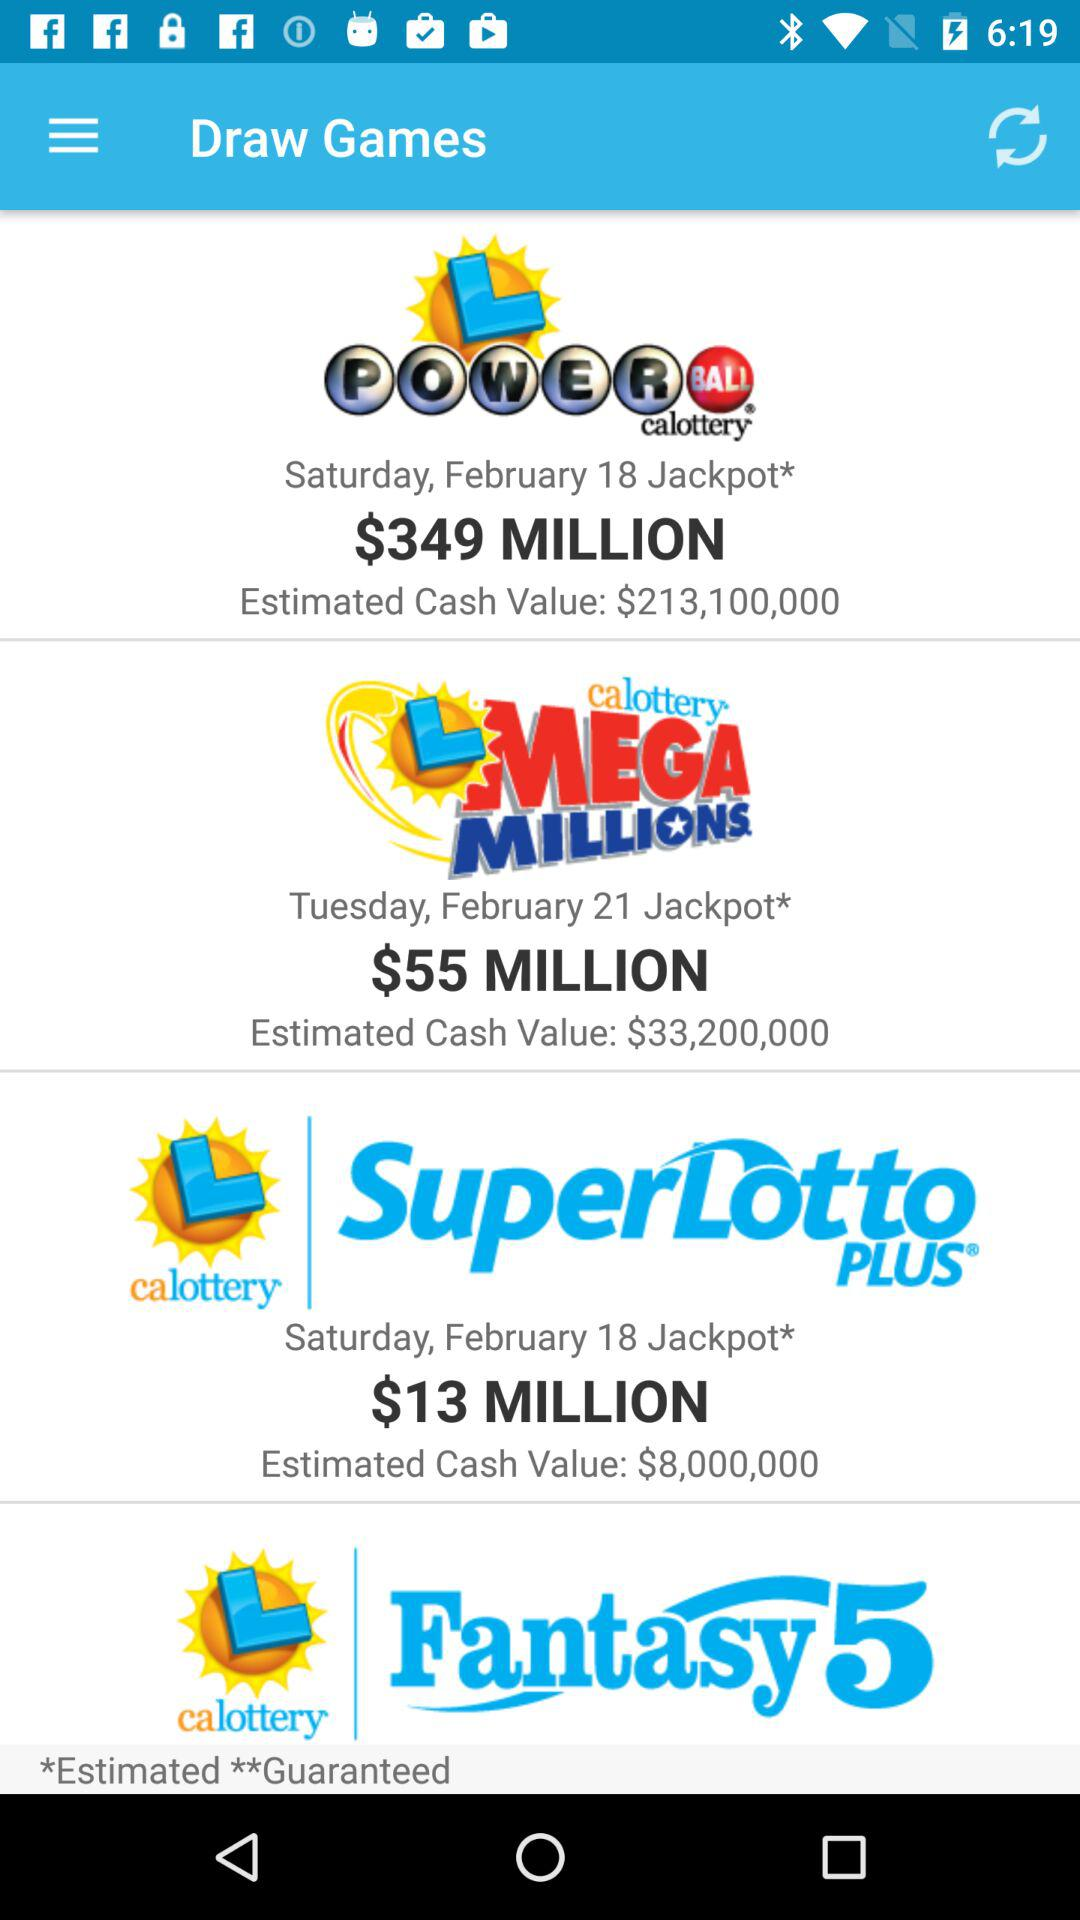What jackpot has an estimated cash value of $213,100,000? The jackpot that has an estimated cash value of $213,100,000 is "L POWERBALL". 